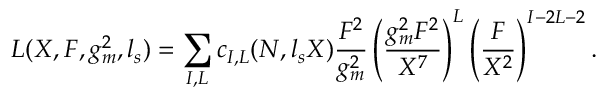<formula> <loc_0><loc_0><loc_500><loc_500>L ( X , F , g _ { m } ^ { 2 } , l _ { s } ) = \sum _ { I , L } c _ { I , L } ( N , l _ { s } X ) { \frac { F ^ { 2 } } { g _ { m } ^ { 2 } } } \left ( { \frac { g _ { m } ^ { 2 } F ^ { 2 } } { X ^ { 7 } } } \right ) ^ { L } \left ( { \frac { F } { X ^ { 2 } } } \right ) ^ { I - 2 L - 2 } .</formula> 